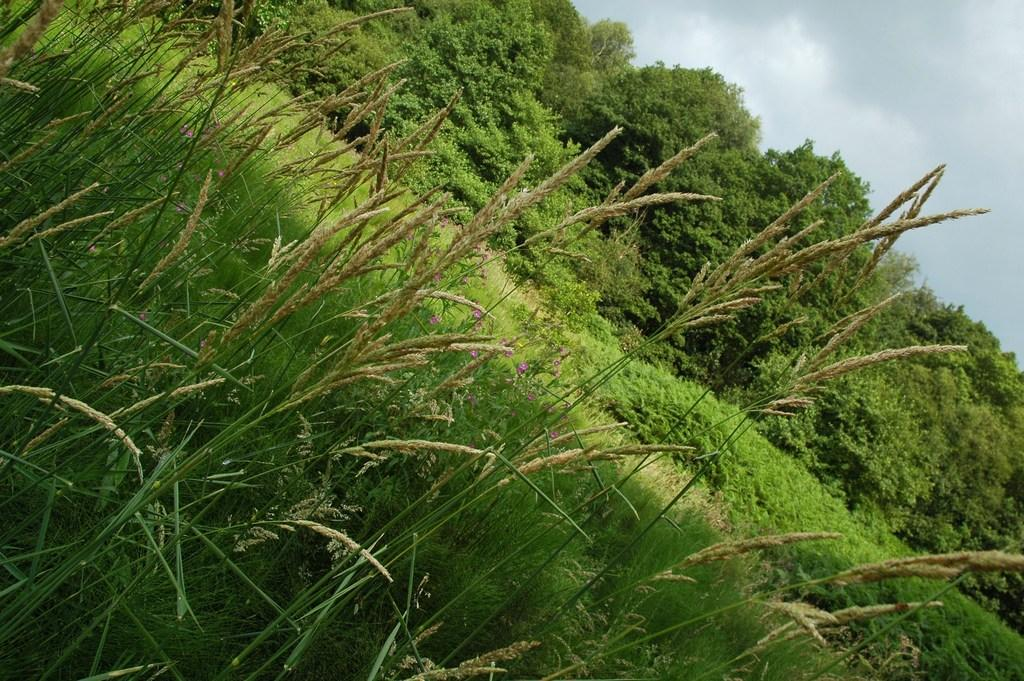What type of vegetation can be seen in the image? There are trees in the image. What is the color of the trees? The trees are green in color. What other colorful elements are present in the image? There are pink colored flowers in the image. What type of ground cover is visible in the image? There is grass in the image. What can be seen in the background of the image? The sky is visible in the background of the image. How many fingers can be seen pointing at the flowers in the image? There are no fingers visible in the image, as it only features trees, pink flowers, grass, and the sky. 